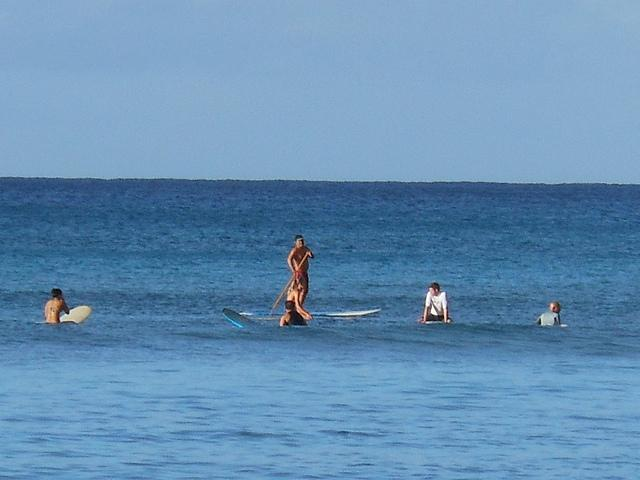What is the man who is standing doing? Please explain your reasoning. rowing. The man is visibly holding a long pole. poles are a part of a paddle that would be seen above the water and a paddle is a traditional wave to move a small craft through water and rowing is another term for paddling. 